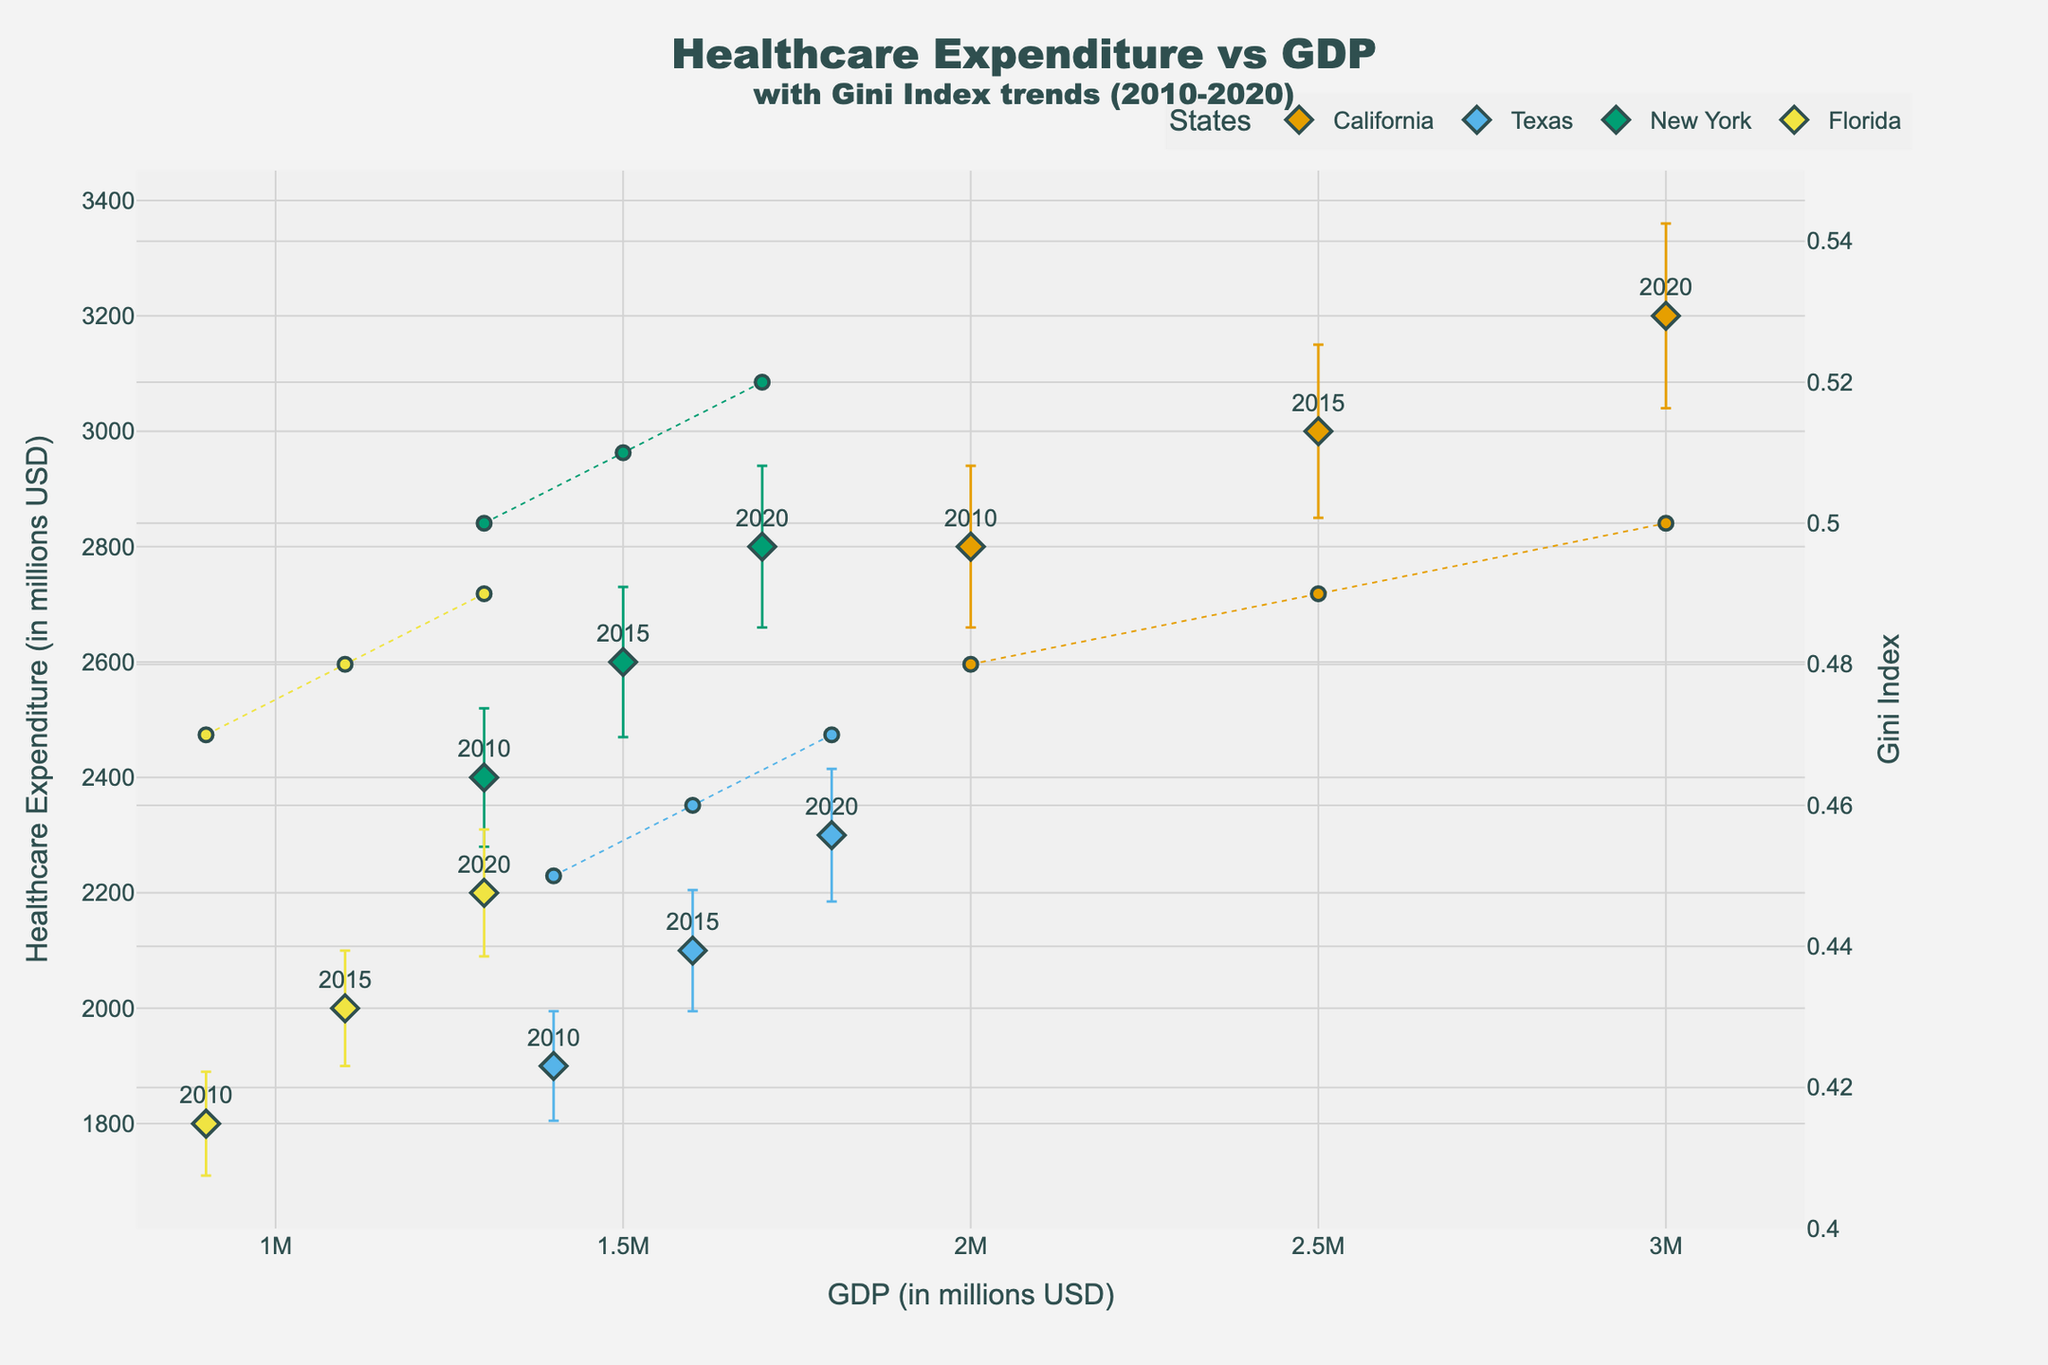What is the title of the figure? The title of a figure is typically found at the top and is meant to give a brief summary of what the figure represents. In this case, it's displayed prominently.
Answer: Healthcare Expenditure vs GDP with Gini Index trends (2010-2020) Which state has the highest Healthcare Expenditure in 2020? To find this, locate the data points labeled '2020' and compare their Healthcare Expenditure values. The highest expenditure point can be identified by looking at the vertical position.
Answer: California How does the Gini Index trend for Florida from 2010 to 2020? Inspect the dashed line representing Florida’s Gini Index. Check the y positions of the points labeled with the respective years for Florida and observe the trend.
Answer: It increases from 0.47 in 2010 to 0.49 in 2020 What is the GDP of Texas in 2015? Find the data point for Texas labeled '2015'. The x-coordinate of that point represents the GDP.
Answer: 1,600,000 USD Compare the Healthcare Expenditures of California and Texas in 2015. Locate the points labeled '2015' for both California and Texas, then compare their y-coordinates which represent the Healthcare Expenditures.
Answer: California's expenditure is 3000, and Texas's is 2100 Which state shows the greatest increase in Healthcare Expenditure from 2010 to 2020? Observe each state's Healthcare Expenditure values for 2010 and 2020. Calculate the difference for each state, and identify which has the highest increase.
Answer: California (increase of 400) Does any state’s Healthcare Expenditure decrease between any two years? Examine the y-values for each state across 2010, 2015, and 2020. Look for any state where the value decreases.
Answer: No How does the Unemployment Rate in 2015 compare for Florida and New York? Compare the y-values of the points labeled '2015' for both states based on the secondary y-axis, noting their respective Unemployment Rates.
Answer: Florida's is 5.7 and New York's is 5.3 What is the average GDP across all states in 2020? Sum the GDP values for all states in 2020 and divide by the number of states (4) to find the average.
Answer: (3,000,000 + 1,800,000 + 1,700,000 + 1,300,000) / 4 = 1,950,000 USD Which state has the highest Gini Index in any given year? Inspect the dashed lines (representing Gini Index trends) and identify the highest point on the secondary y-axis across all years.
Answer: New York in 2020 (0.52) 